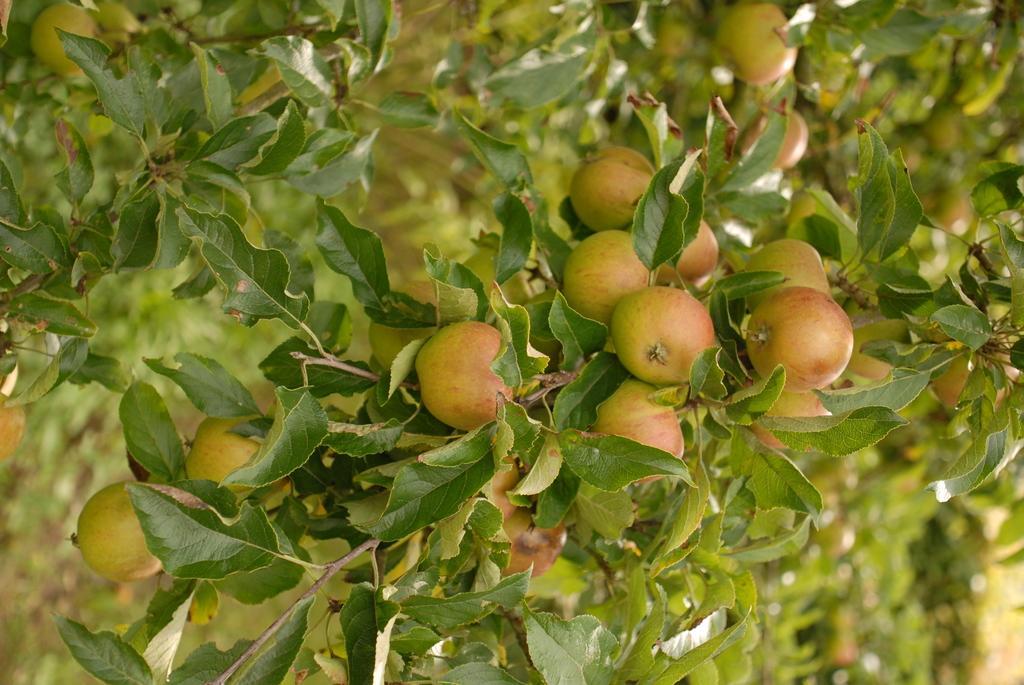Please provide a concise description of this image. In the middle of this image, there is a branch of a tree having fruits and green color leaves. In the background, there are other trees having fruits and leaves. 